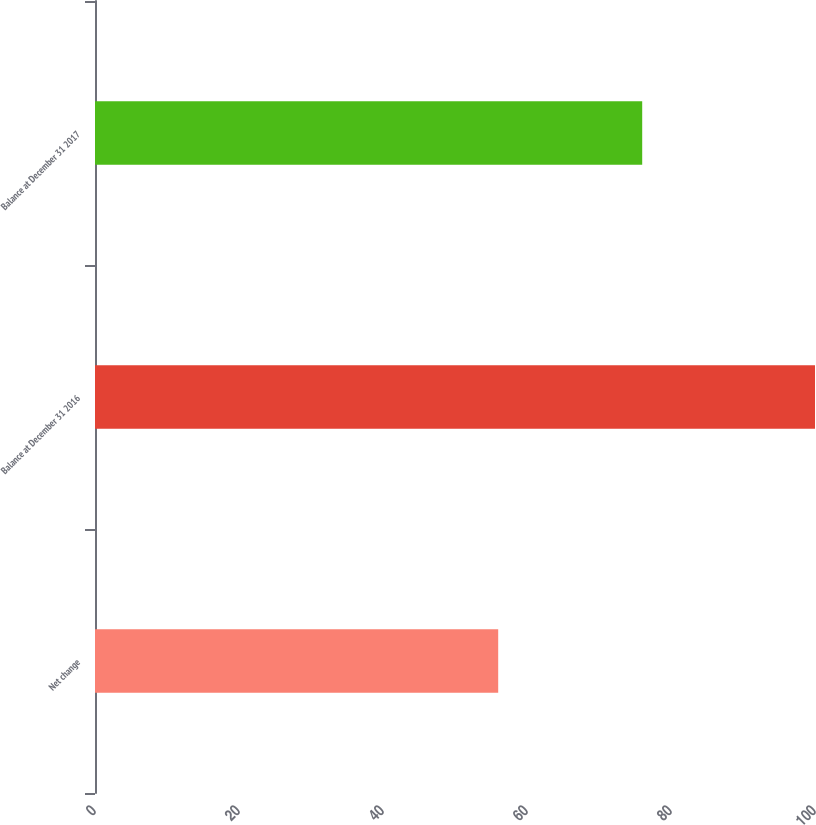Convert chart to OTSL. <chart><loc_0><loc_0><loc_500><loc_500><bar_chart><fcel>Net change<fcel>Balance at December 31 2016<fcel>Balance at December 31 2017<nl><fcel>56<fcel>100<fcel>76<nl></chart> 